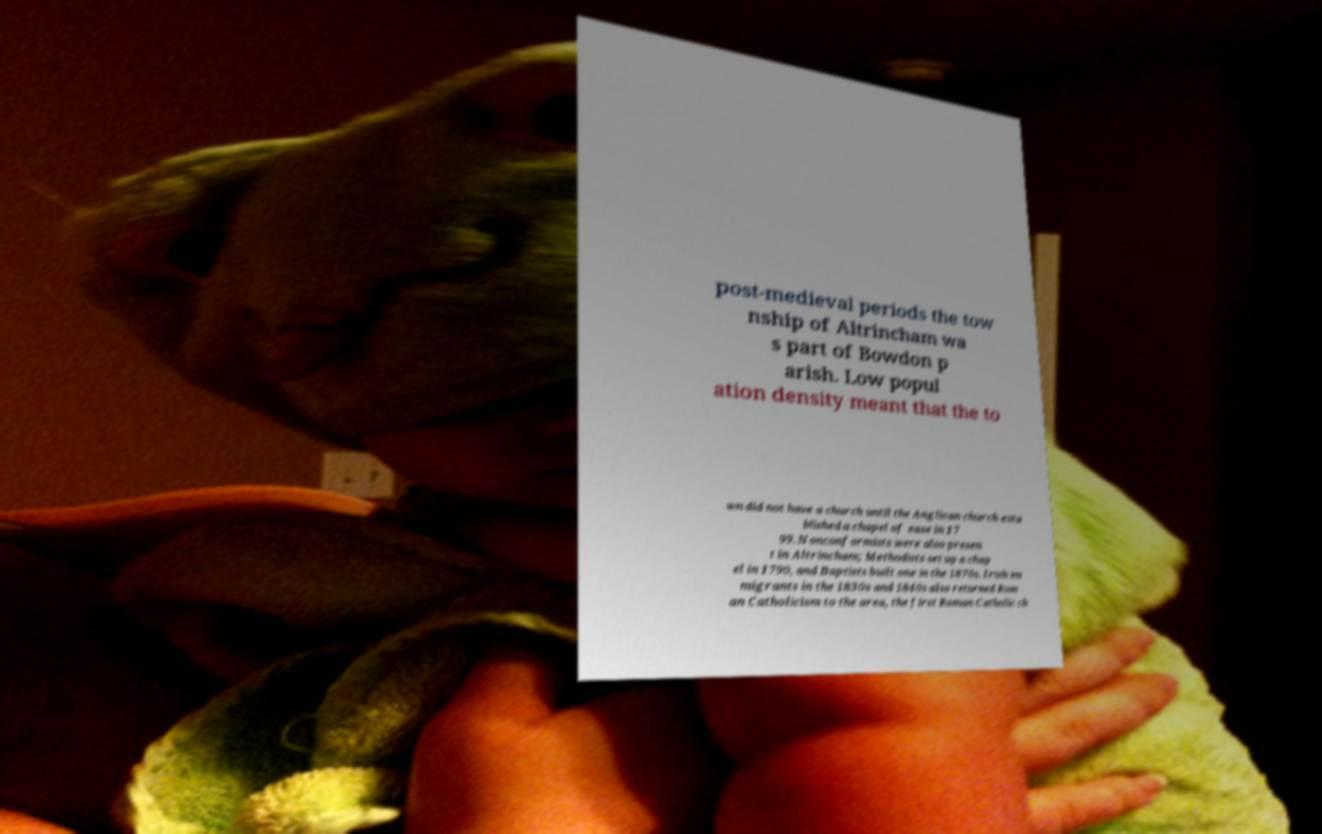Can you read and provide the text displayed in the image?This photo seems to have some interesting text. Can you extract and type it out for me? post-medieval periods the tow nship of Altrincham wa s part of Bowdon p arish. Low popul ation density meant that the to wn did not have a church until the Anglican church esta blished a chapel of ease in 17 99. Nonconformists were also presen t in Altrincham; Methodists set up a chap el in 1790, and Baptists built one in the 1870s. Irish im migrants in the 1830s and 1840s also returned Rom an Catholicism to the area, the first Roman Catholic ch 